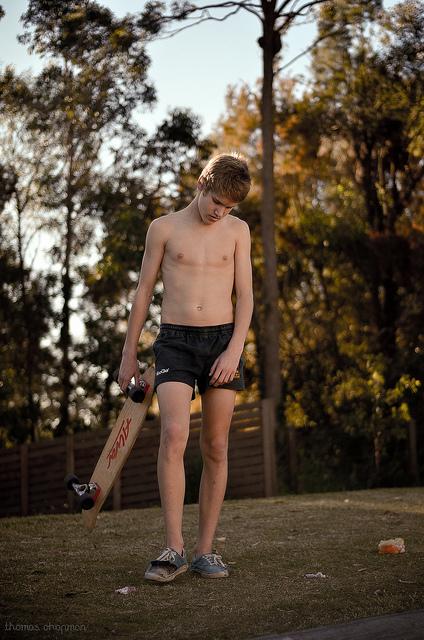What is the shadow of?
Give a very brief answer. Trees. Brand of the man's shoes?
Short answer required. Sketchers. Which direction is the boy looking?
Concise answer only. Down. What sport is being played?
Give a very brief answer. Skateboarding. How old is this photo?
Keep it brief. New. Color of men's shorts?
Write a very short answer. Black. Is the boy likely to wear the same clothes if he went to church?
Keep it brief. No. Does this child look to be a teenager?
Give a very brief answer. Yes. What is the boy holding?
Quick response, please. Skateboard. 